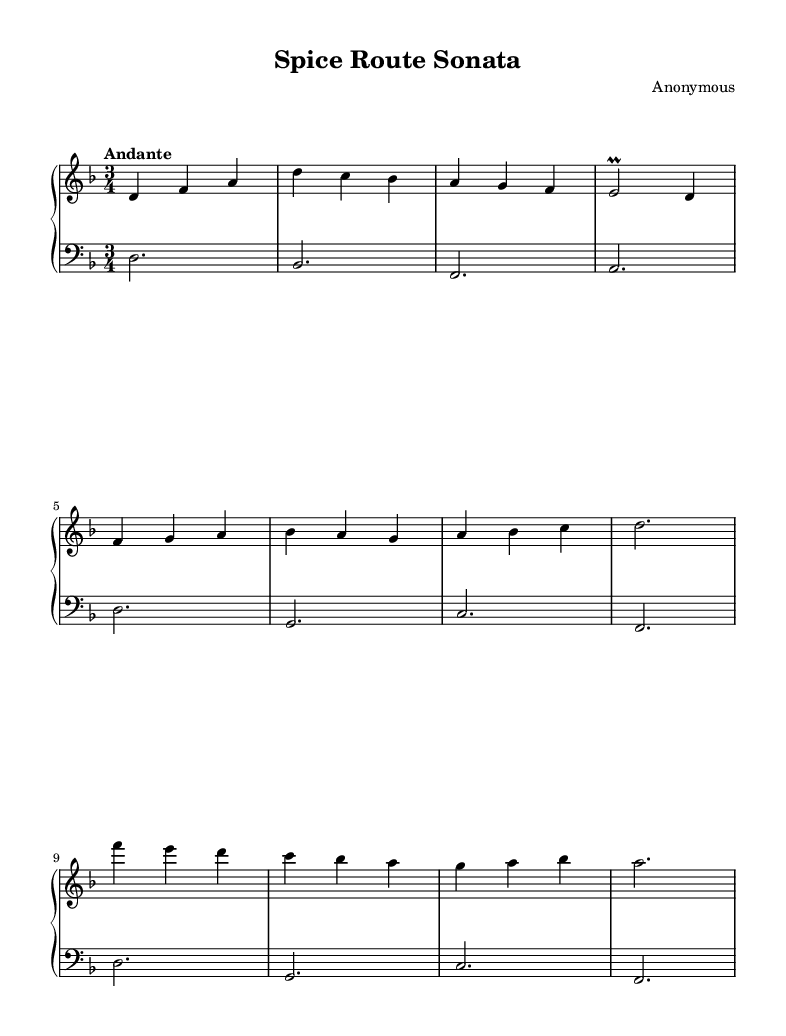What is the key signature of this music? The key signature in the score is indicated by the sharp or flat symbols at the beginning of the staff. In this case, it shows one flat, which corresponds to the key of D minor.
Answer: D minor What is the time signature of this piece? The time signature is displayed as a fraction at the beginning of the score. Here, it shows three beats per measure, indicating that it is in 3/4 time.
Answer: 3/4 What is the tempo marking of this composition? The tempo marking is found above the staff, indicating the speed of the piece. In this score, it reads "Andante," which denotes a moderate tempo.
Answer: Andante How many sections does the music score contain? The piece is divided into three distinct sections, marked A, B, and C, as indicated by the structural segmentation in the right-hand part.
Answer: Three What is the highest note in the right hand part? To find the highest note in the right hand part, we must look through the notes written in the section. The highest note is f' (the note f one octave above middle C).
Answer: f' Which hand plays the bass notes in this composition? The left hand is designated to play the bass notes, as indicated by its placement on the lower staff. The clef used is the bass clef, which is specifically for lower pitches.
Answer: Left hand What is the rhythmic pattern used predominantly in this score? The rhythmic pattern is determined by counting the note values present in the measures. Most of this piece utilizes quarter notes and half notes, contributing to its 3/4 time feel.
Answer: 3/4 